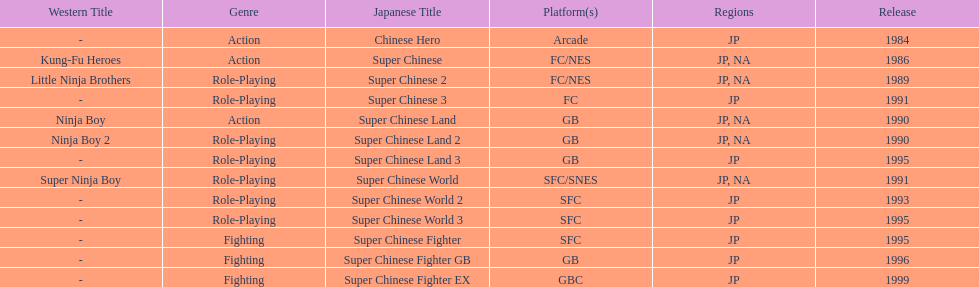Out of the titles made available in north america, which had the smallest amount of releases? Super Chinese World. 